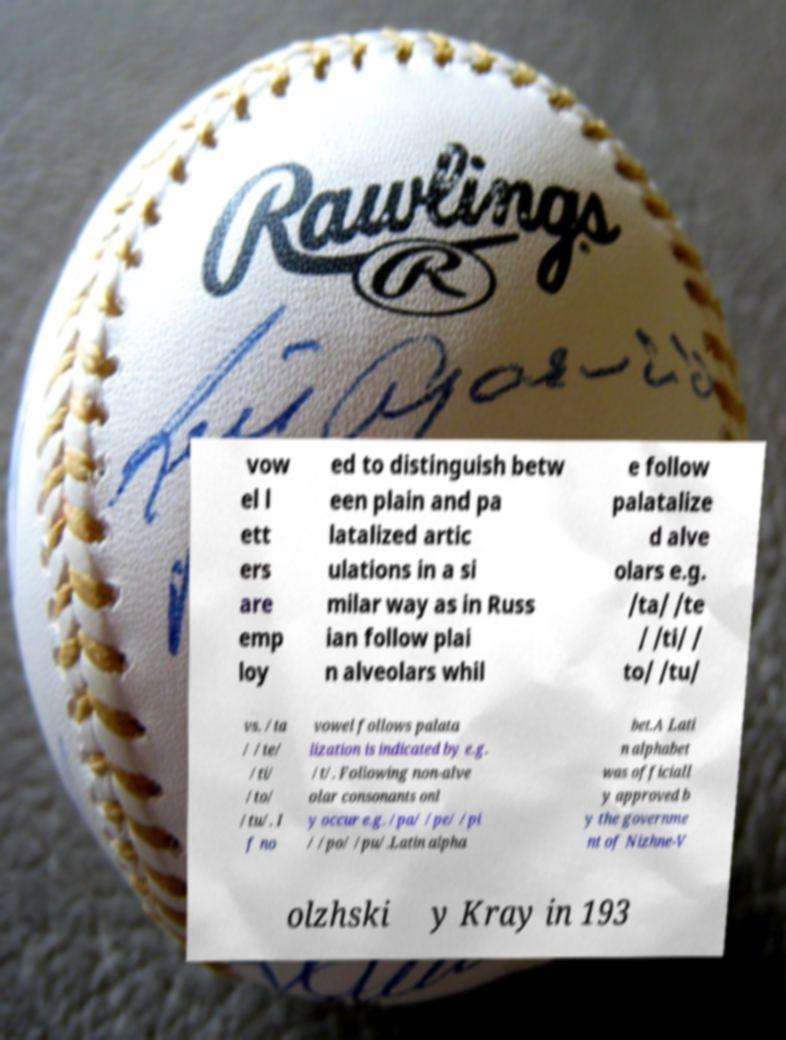Please read and relay the text visible in this image. What does it say? vow el l ett ers are emp loy ed to distinguish betw een plain and pa latalized artic ulations in a si milar way as in Russ ian follow plai n alveolars whil e follow palatalize d alve olars e.g. /ta/ /te / /ti/ / to/ /tu/ vs. /ta / /te/ /ti/ /to/ /tu/. I f no vowel follows palata lization is indicated by e.g. /t/. Following non-alve olar consonants onl y occur e.g. /pa/ /pe/ /pi / /po/ /pu/.Latin alpha bet.A Lati n alphabet was officiall y approved b y the governme nt of Nizhne-V olzhski y Kray in 193 